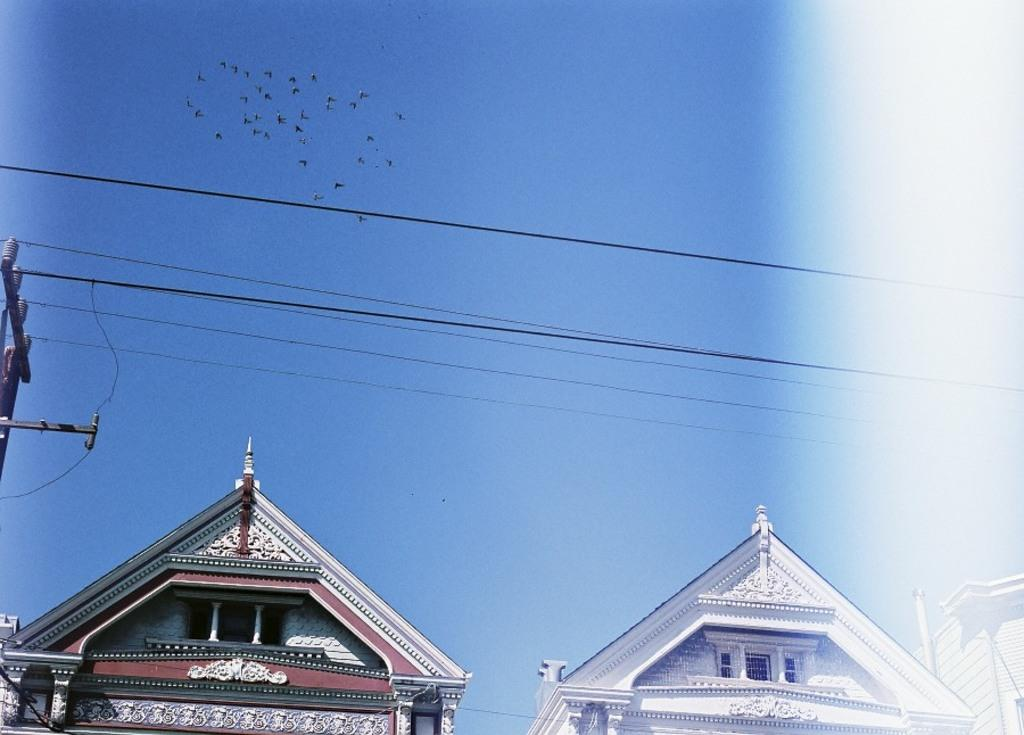What type of structures can be seen in the image? There are buildings in the image. What is attached to the buildings? There is a pole in the image, which may be attached to the buildings. What else can be seen in the image besides the buildings and pole? There are wires and birds visible in the image. What part of the natural environment is visible in the image? The sky is visible in the image. Can you hear the birds coughing in the image? There is no sound in the image, and therefore it is not possible to hear the birds coughing. 